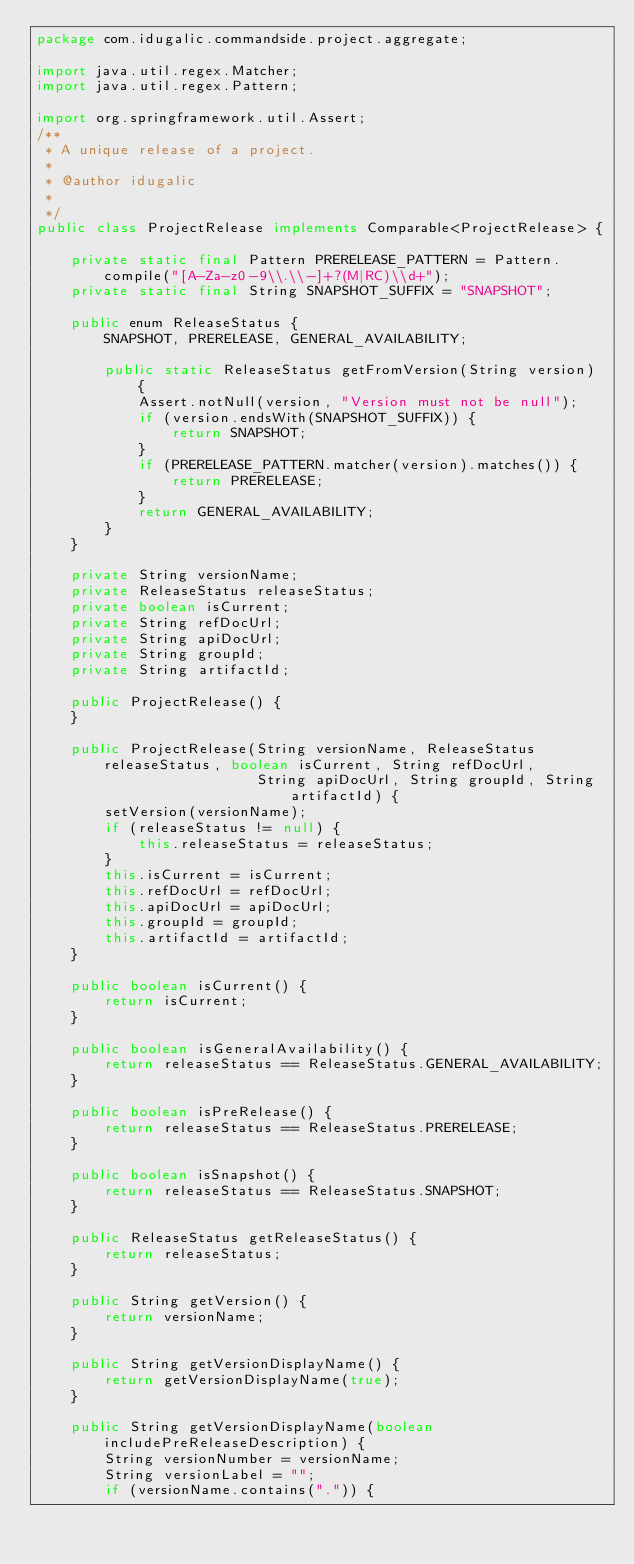Convert code to text. <code><loc_0><loc_0><loc_500><loc_500><_Java_>package com.idugalic.commandside.project.aggregate;

import java.util.regex.Matcher;
import java.util.regex.Pattern;

import org.springframework.util.Assert;
/**
 * A unique release of a project.
 * 
 * @author idugalic
 *
 */
public class ProjectRelease implements Comparable<ProjectRelease> {

    private static final Pattern PRERELEASE_PATTERN = Pattern.compile("[A-Za-z0-9\\.\\-]+?(M|RC)\\d+");
    private static final String SNAPSHOT_SUFFIX = "SNAPSHOT";

    public enum ReleaseStatus {
        SNAPSHOT, PRERELEASE, GENERAL_AVAILABILITY;

        public static ReleaseStatus getFromVersion(String version) {
            Assert.notNull(version, "Version must not be null");
            if (version.endsWith(SNAPSHOT_SUFFIX)) {
                return SNAPSHOT;
            }
            if (PRERELEASE_PATTERN.matcher(version).matches()) {
                return PRERELEASE;
            }
            return GENERAL_AVAILABILITY;
        }
    }

    private String versionName;
    private ReleaseStatus releaseStatus;
    private boolean isCurrent;
    private String refDocUrl;
    private String apiDocUrl;
    private String groupId;
    private String artifactId;

    public ProjectRelease() {
    }

    public ProjectRelease(String versionName, ReleaseStatus releaseStatus, boolean isCurrent, String refDocUrl,
                          String apiDocUrl, String groupId, String artifactId) {
        setVersion(versionName);
        if (releaseStatus != null) {
            this.releaseStatus = releaseStatus;
        }
        this.isCurrent = isCurrent;
        this.refDocUrl = refDocUrl;
        this.apiDocUrl = apiDocUrl;
        this.groupId = groupId;
        this.artifactId = artifactId;
    }

    public boolean isCurrent() {
        return isCurrent;
    }

    public boolean isGeneralAvailability() {
        return releaseStatus == ReleaseStatus.GENERAL_AVAILABILITY;
    }

    public boolean isPreRelease() {
        return releaseStatus == ReleaseStatus.PRERELEASE;
    }

    public boolean isSnapshot() {
        return releaseStatus == ReleaseStatus.SNAPSHOT;
    }

    public ReleaseStatus getReleaseStatus() {
        return releaseStatus;
    }

    public String getVersion() {
        return versionName;
    }

    public String getVersionDisplayName() {
        return getVersionDisplayName(true);
    }

    public String getVersionDisplayName(boolean includePreReleaseDescription) {
        String versionNumber = versionName;
        String versionLabel = "";
        if (versionName.contains(".")) {</code> 